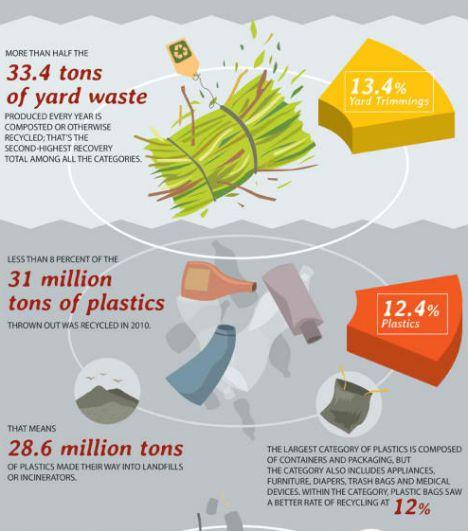Point out several critical features in this image. According to the information provided, approximately 13.4% of bio waste from yards is recycled. In 2010, an estimated 28.6 million tons of plastic were not recycled. This is troubling as it highlights the ongoing issue of plastic waste and the need for more effective recycling efforts. It is important to note that this is just one year, and the amount of plastic waste not recycled has likely increased since then. 